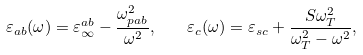Convert formula to latex. <formula><loc_0><loc_0><loc_500><loc_500>\varepsilon _ { a b } ( \omega ) = \varepsilon _ { \infty } ^ { a b } - \frac { \omega _ { p a b } ^ { 2 } } { \omega ^ { 2 } } , \quad \varepsilon _ { c } ( \omega ) = \varepsilon _ { s c } + \frac { S \omega _ { T } ^ { 2 } } { \omega _ { T } ^ { 2 } - \omega ^ { 2 } } ,</formula> 